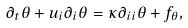<formula> <loc_0><loc_0><loc_500><loc_500>\partial _ { t } \theta + u _ { i } \partial _ { i } \theta = \kappa \partial _ { i i } \theta + f _ { \theta } ,</formula> 